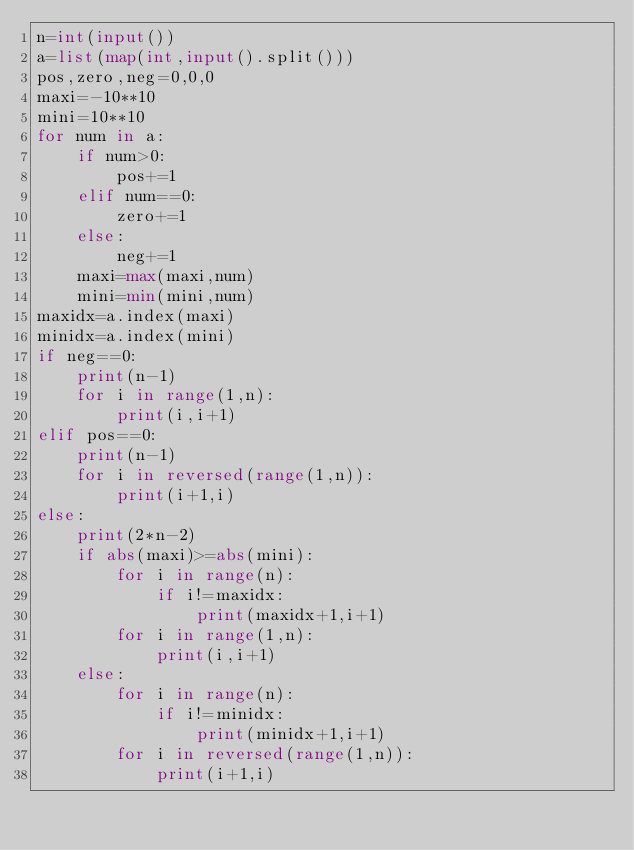<code> <loc_0><loc_0><loc_500><loc_500><_Python_>n=int(input())
a=list(map(int,input().split()))
pos,zero,neg=0,0,0
maxi=-10**10
mini=10**10
for num in a:
    if num>0:
        pos+=1
    elif num==0:
        zero+=1
    else:
        neg+=1
    maxi=max(maxi,num)
    mini=min(mini,num)
maxidx=a.index(maxi)
minidx=a.index(mini)
if neg==0:
    print(n-1)
    for i in range(1,n):
        print(i,i+1)
elif pos==0:
    print(n-1)
    for i in reversed(range(1,n)):
        print(i+1,i)
else:
    print(2*n-2)
    if abs(maxi)>=abs(mini):
        for i in range(n):
            if i!=maxidx:
                print(maxidx+1,i+1)
        for i in range(1,n):
            print(i,i+1)
    else:
        for i in range(n):
            if i!=minidx:
                print(minidx+1,i+1)
        for i in reversed(range(1,n)):
            print(i+1,i)</code> 